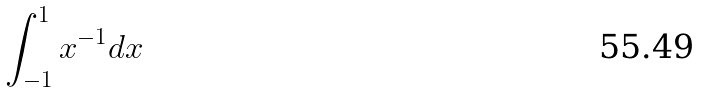Convert formula to latex. <formula><loc_0><loc_0><loc_500><loc_500>\int _ { - 1 } ^ { 1 } x ^ { - 1 } d x</formula> 